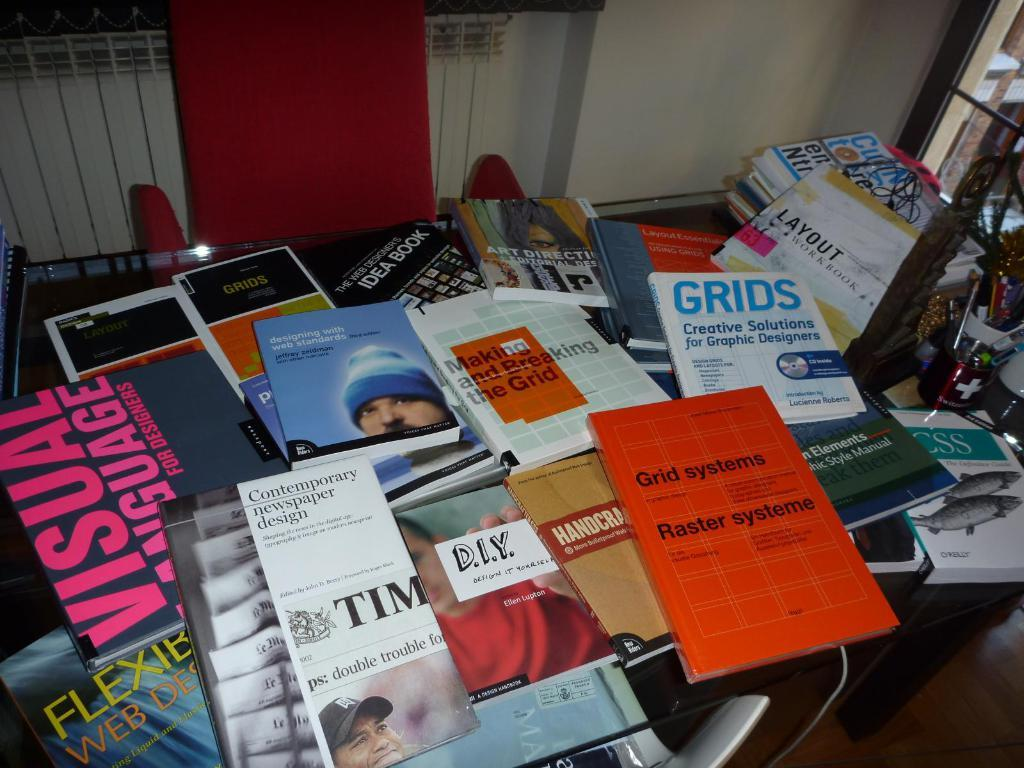<image>
Present a compact description of the photo's key features. the word grids that is on a little book 